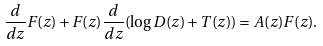Convert formula to latex. <formula><loc_0><loc_0><loc_500><loc_500>\frac { d } { d z } F ( z ) + F ( z ) \frac { d } { d z } ( \log D ( z ) + T ( z ) ) = A ( z ) F ( z ) .</formula> 